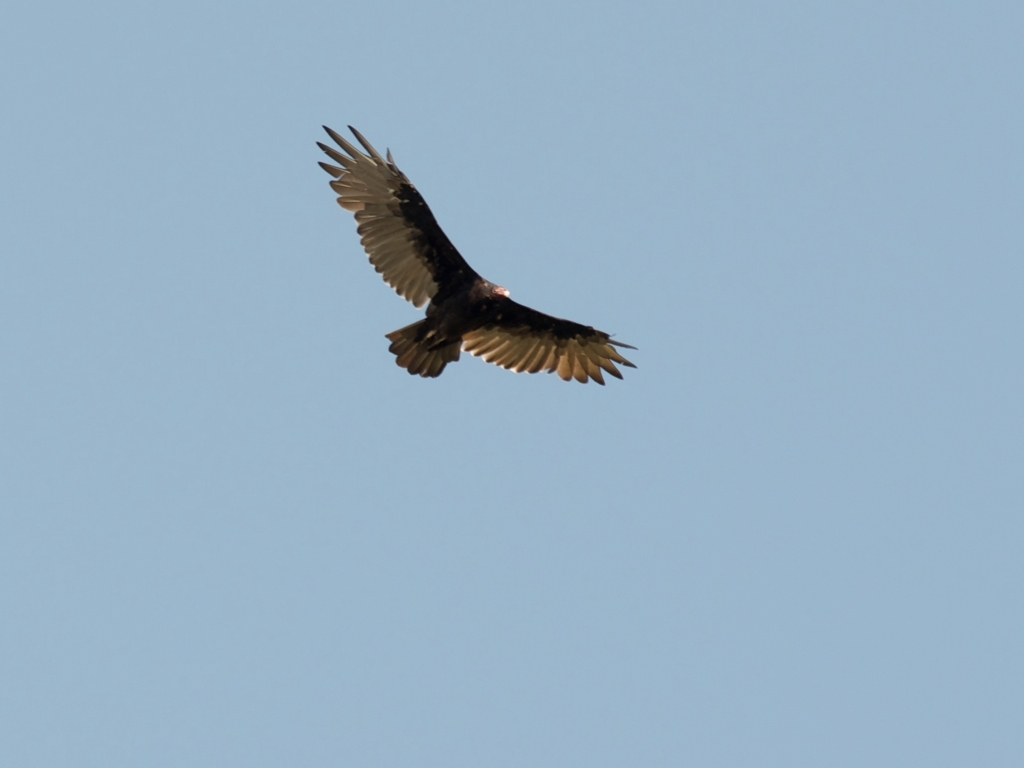Can you infer anything about the species or characteristics of the bird? Based on the visual information, we can see that the bird has a broad wingspan and a tail that is spread out, which are typical features of raptors, like eagles or buzzards. The coloration appears to be dark with lighter feather tips, which might be characteristic of a juvenile or a specific species within that group. However, without more specific details or a closer view, it is challenging to determine the exact species. The bird’s form, observed from this perspective, reflects an adaptation for soaring and hunting, indicating a predator adept at navigating open skies. 